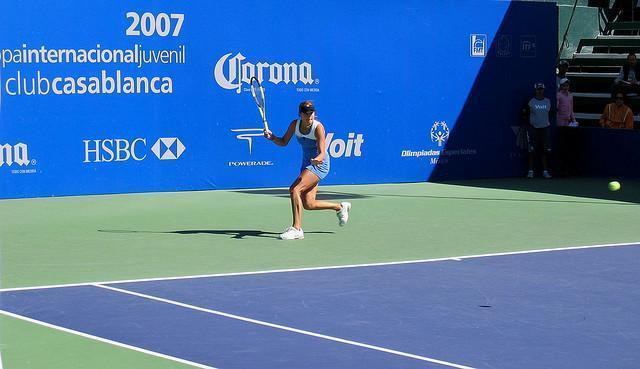How many people are in the photo?
Give a very brief answer. 2. 